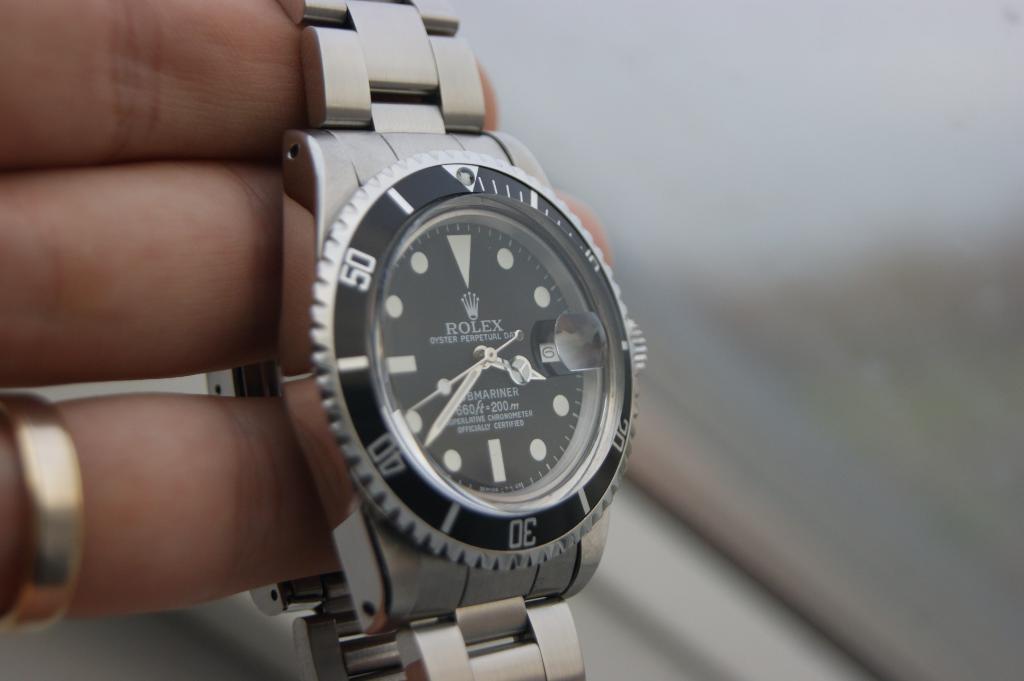What brand of watch is this?
Your response must be concise. Rolex. What time is it?
Your answer should be very brief. 3:38. 